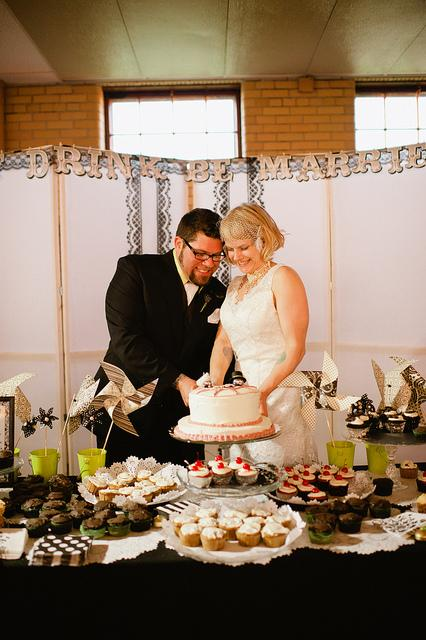What are the two touching? Please explain your reasoning. cake. They are cutting a food item at the same time while dressed in bride and groom attire in a room filled with trays of cupcakes. 